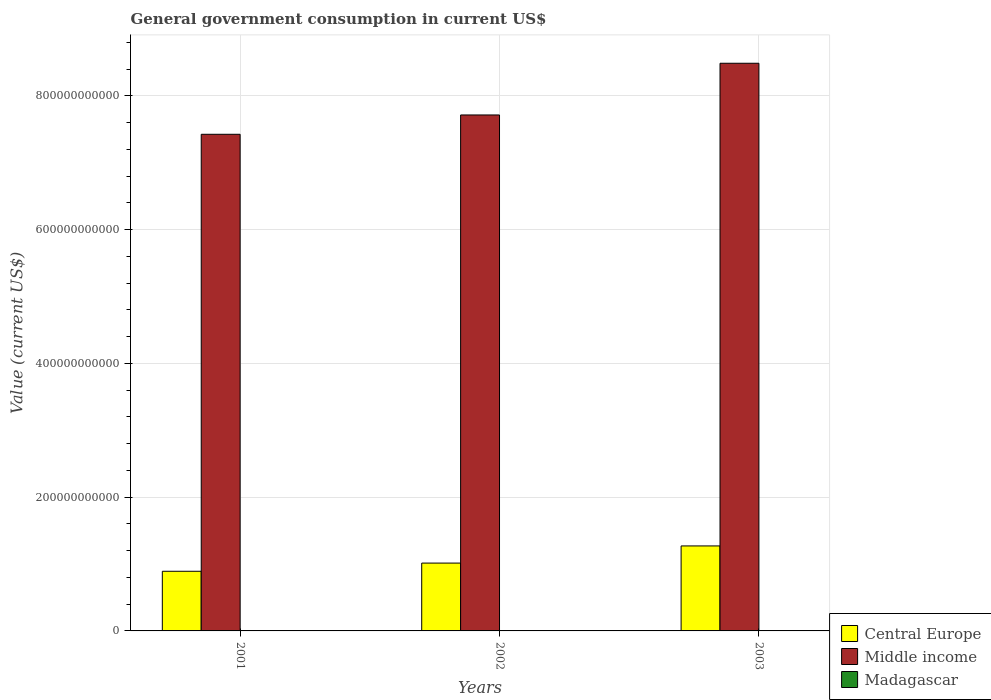How many groups of bars are there?
Provide a short and direct response. 3. What is the government conusmption in Middle income in 2001?
Provide a short and direct response. 7.43e+11. Across all years, what is the maximum government conusmption in Central Europe?
Make the answer very short. 1.27e+11. Across all years, what is the minimum government conusmption in Central Europe?
Provide a succinct answer. 8.92e+1. In which year was the government conusmption in Madagascar maximum?
Provide a succinct answer. 2003. What is the total government conusmption in Central Europe in the graph?
Your response must be concise. 3.18e+11. What is the difference between the government conusmption in Central Europe in 2001 and that in 2003?
Give a very brief answer. -3.79e+1. What is the difference between the government conusmption in Middle income in 2001 and the government conusmption in Madagascar in 2002?
Your response must be concise. 7.42e+11. What is the average government conusmption in Madagascar per year?
Provide a short and direct response. 4.25e+08. In the year 2002, what is the difference between the government conusmption in Middle income and government conusmption in Madagascar?
Offer a very short reply. 7.71e+11. In how many years, is the government conusmption in Middle income greater than 120000000000 US$?
Your answer should be compact. 3. What is the ratio of the government conusmption in Middle income in 2002 to that in 2003?
Ensure brevity in your answer.  0.91. Is the difference between the government conusmption in Middle income in 2001 and 2002 greater than the difference between the government conusmption in Madagascar in 2001 and 2002?
Offer a very short reply. No. What is the difference between the highest and the second highest government conusmption in Central Europe?
Offer a very short reply. 2.57e+1. What is the difference between the highest and the lowest government conusmption in Middle income?
Provide a short and direct response. 1.06e+11. What does the 2nd bar from the right in 2001 represents?
Your response must be concise. Middle income. Is it the case that in every year, the sum of the government conusmption in Middle income and government conusmption in Madagascar is greater than the government conusmption in Central Europe?
Give a very brief answer. Yes. How many bars are there?
Keep it short and to the point. 9. How many years are there in the graph?
Your response must be concise. 3. What is the difference between two consecutive major ticks on the Y-axis?
Ensure brevity in your answer.  2.00e+11. Are the values on the major ticks of Y-axis written in scientific E-notation?
Keep it short and to the point. No. Does the graph contain any zero values?
Your response must be concise. No. Does the graph contain grids?
Offer a terse response. Yes. Where does the legend appear in the graph?
Make the answer very short. Bottom right. How many legend labels are there?
Provide a short and direct response. 3. How are the legend labels stacked?
Give a very brief answer. Vertical. What is the title of the graph?
Offer a terse response. General government consumption in current US$. Does "Kuwait" appear as one of the legend labels in the graph?
Ensure brevity in your answer.  No. What is the label or title of the X-axis?
Your answer should be compact. Years. What is the label or title of the Y-axis?
Your answer should be very brief. Value (current US$). What is the Value (current US$) in Central Europe in 2001?
Keep it short and to the point. 8.92e+1. What is the Value (current US$) in Middle income in 2001?
Offer a very short reply. 7.43e+11. What is the Value (current US$) in Madagascar in 2001?
Make the answer very short. 4.12e+08. What is the Value (current US$) in Central Europe in 2002?
Your response must be concise. 1.01e+11. What is the Value (current US$) of Middle income in 2002?
Keep it short and to the point. 7.72e+11. What is the Value (current US$) in Madagascar in 2002?
Your answer should be very brief. 3.58e+08. What is the Value (current US$) in Central Europe in 2003?
Give a very brief answer. 1.27e+11. What is the Value (current US$) of Middle income in 2003?
Offer a very short reply. 8.49e+11. What is the Value (current US$) of Madagascar in 2003?
Ensure brevity in your answer.  5.05e+08. Across all years, what is the maximum Value (current US$) of Central Europe?
Offer a terse response. 1.27e+11. Across all years, what is the maximum Value (current US$) in Middle income?
Offer a very short reply. 8.49e+11. Across all years, what is the maximum Value (current US$) in Madagascar?
Your answer should be very brief. 5.05e+08. Across all years, what is the minimum Value (current US$) in Central Europe?
Provide a succinct answer. 8.92e+1. Across all years, what is the minimum Value (current US$) of Middle income?
Your answer should be very brief. 7.43e+11. Across all years, what is the minimum Value (current US$) of Madagascar?
Your answer should be compact. 3.58e+08. What is the total Value (current US$) in Central Europe in the graph?
Keep it short and to the point. 3.18e+11. What is the total Value (current US$) in Middle income in the graph?
Your answer should be very brief. 2.36e+12. What is the total Value (current US$) in Madagascar in the graph?
Your answer should be compact. 1.27e+09. What is the difference between the Value (current US$) in Central Europe in 2001 and that in 2002?
Offer a terse response. -1.22e+1. What is the difference between the Value (current US$) in Middle income in 2001 and that in 2002?
Give a very brief answer. -2.89e+1. What is the difference between the Value (current US$) in Madagascar in 2001 and that in 2002?
Offer a terse response. 5.40e+07. What is the difference between the Value (current US$) of Central Europe in 2001 and that in 2003?
Your answer should be very brief. -3.79e+1. What is the difference between the Value (current US$) in Middle income in 2001 and that in 2003?
Give a very brief answer. -1.06e+11. What is the difference between the Value (current US$) in Madagascar in 2001 and that in 2003?
Ensure brevity in your answer.  -9.34e+07. What is the difference between the Value (current US$) of Central Europe in 2002 and that in 2003?
Give a very brief answer. -2.57e+1. What is the difference between the Value (current US$) in Middle income in 2002 and that in 2003?
Ensure brevity in your answer.  -7.73e+1. What is the difference between the Value (current US$) of Madagascar in 2002 and that in 2003?
Offer a very short reply. -1.47e+08. What is the difference between the Value (current US$) in Central Europe in 2001 and the Value (current US$) in Middle income in 2002?
Offer a terse response. -6.82e+11. What is the difference between the Value (current US$) in Central Europe in 2001 and the Value (current US$) in Madagascar in 2002?
Your answer should be compact. 8.89e+1. What is the difference between the Value (current US$) in Middle income in 2001 and the Value (current US$) in Madagascar in 2002?
Your answer should be very brief. 7.42e+11. What is the difference between the Value (current US$) in Central Europe in 2001 and the Value (current US$) in Middle income in 2003?
Provide a short and direct response. -7.60e+11. What is the difference between the Value (current US$) in Central Europe in 2001 and the Value (current US$) in Madagascar in 2003?
Your response must be concise. 8.87e+1. What is the difference between the Value (current US$) in Middle income in 2001 and the Value (current US$) in Madagascar in 2003?
Your answer should be very brief. 7.42e+11. What is the difference between the Value (current US$) of Central Europe in 2002 and the Value (current US$) of Middle income in 2003?
Provide a short and direct response. -7.48e+11. What is the difference between the Value (current US$) of Central Europe in 2002 and the Value (current US$) of Madagascar in 2003?
Keep it short and to the point. 1.01e+11. What is the difference between the Value (current US$) of Middle income in 2002 and the Value (current US$) of Madagascar in 2003?
Give a very brief answer. 7.71e+11. What is the average Value (current US$) of Central Europe per year?
Your answer should be compact. 1.06e+11. What is the average Value (current US$) of Middle income per year?
Your answer should be compact. 7.88e+11. What is the average Value (current US$) in Madagascar per year?
Your response must be concise. 4.25e+08. In the year 2001, what is the difference between the Value (current US$) of Central Europe and Value (current US$) of Middle income?
Give a very brief answer. -6.54e+11. In the year 2001, what is the difference between the Value (current US$) of Central Europe and Value (current US$) of Madagascar?
Make the answer very short. 8.88e+1. In the year 2001, what is the difference between the Value (current US$) of Middle income and Value (current US$) of Madagascar?
Keep it short and to the point. 7.42e+11. In the year 2002, what is the difference between the Value (current US$) in Central Europe and Value (current US$) in Middle income?
Your answer should be compact. -6.70e+11. In the year 2002, what is the difference between the Value (current US$) of Central Europe and Value (current US$) of Madagascar?
Offer a very short reply. 1.01e+11. In the year 2002, what is the difference between the Value (current US$) of Middle income and Value (current US$) of Madagascar?
Offer a terse response. 7.71e+11. In the year 2003, what is the difference between the Value (current US$) in Central Europe and Value (current US$) in Middle income?
Your answer should be very brief. -7.22e+11. In the year 2003, what is the difference between the Value (current US$) in Central Europe and Value (current US$) in Madagascar?
Provide a succinct answer. 1.27e+11. In the year 2003, what is the difference between the Value (current US$) of Middle income and Value (current US$) of Madagascar?
Make the answer very short. 8.48e+11. What is the ratio of the Value (current US$) in Central Europe in 2001 to that in 2002?
Offer a very short reply. 0.88. What is the ratio of the Value (current US$) in Middle income in 2001 to that in 2002?
Keep it short and to the point. 0.96. What is the ratio of the Value (current US$) of Madagascar in 2001 to that in 2002?
Offer a terse response. 1.15. What is the ratio of the Value (current US$) in Central Europe in 2001 to that in 2003?
Offer a very short reply. 0.7. What is the ratio of the Value (current US$) in Middle income in 2001 to that in 2003?
Offer a terse response. 0.87. What is the ratio of the Value (current US$) of Madagascar in 2001 to that in 2003?
Make the answer very short. 0.82. What is the ratio of the Value (current US$) of Central Europe in 2002 to that in 2003?
Your answer should be very brief. 0.8. What is the ratio of the Value (current US$) of Middle income in 2002 to that in 2003?
Ensure brevity in your answer.  0.91. What is the ratio of the Value (current US$) in Madagascar in 2002 to that in 2003?
Provide a succinct answer. 0.71. What is the difference between the highest and the second highest Value (current US$) of Central Europe?
Keep it short and to the point. 2.57e+1. What is the difference between the highest and the second highest Value (current US$) of Middle income?
Offer a very short reply. 7.73e+1. What is the difference between the highest and the second highest Value (current US$) in Madagascar?
Make the answer very short. 9.34e+07. What is the difference between the highest and the lowest Value (current US$) of Central Europe?
Provide a succinct answer. 3.79e+1. What is the difference between the highest and the lowest Value (current US$) of Middle income?
Your response must be concise. 1.06e+11. What is the difference between the highest and the lowest Value (current US$) in Madagascar?
Offer a terse response. 1.47e+08. 